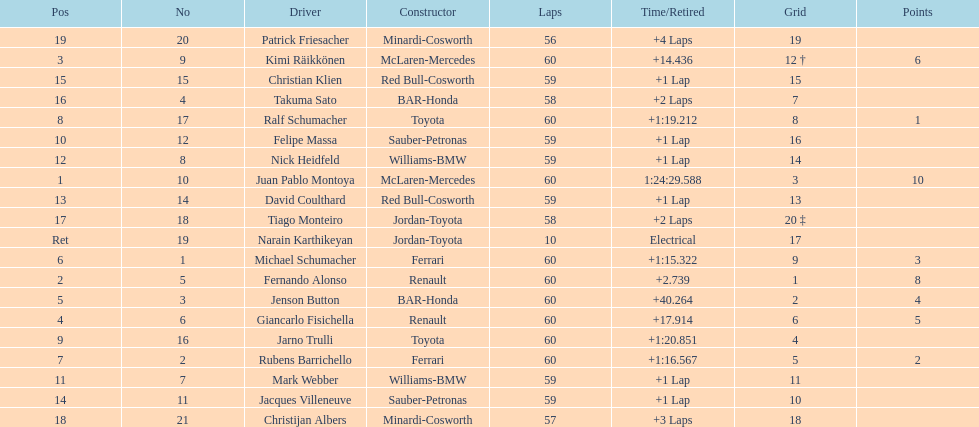Which driver has the least amount of points? Ralf Schumacher. 